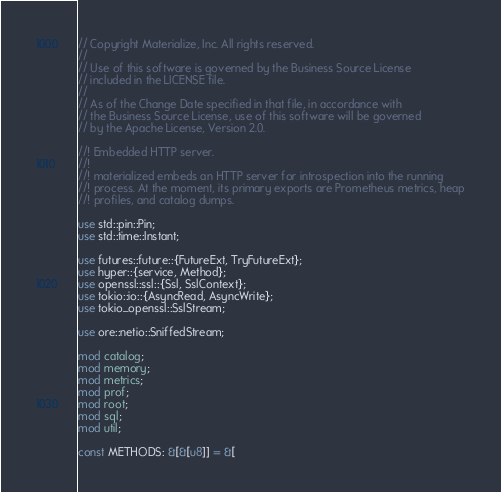<code> <loc_0><loc_0><loc_500><loc_500><_Rust_>// Copyright Materialize, Inc. All rights reserved.
//
// Use of this software is governed by the Business Source License
// included in the LICENSE file.
//
// As of the Change Date specified in that file, in accordance with
// the Business Source License, use of this software will be governed
// by the Apache License, Version 2.0.

//! Embedded HTTP server.
//!
//! materialized embeds an HTTP server for introspection into the running
//! process. At the moment, its primary exports are Prometheus metrics, heap
//! profiles, and catalog dumps.

use std::pin::Pin;
use std::time::Instant;

use futures::future::{FutureExt, TryFutureExt};
use hyper::{service, Method};
use openssl::ssl::{Ssl, SslContext};
use tokio::io::{AsyncRead, AsyncWrite};
use tokio_openssl::SslStream;

use ore::netio::SniffedStream;

mod catalog;
mod memory;
mod metrics;
mod prof;
mod root;
mod sql;
mod util;

const METHODS: &[&[u8]] = &[</code> 